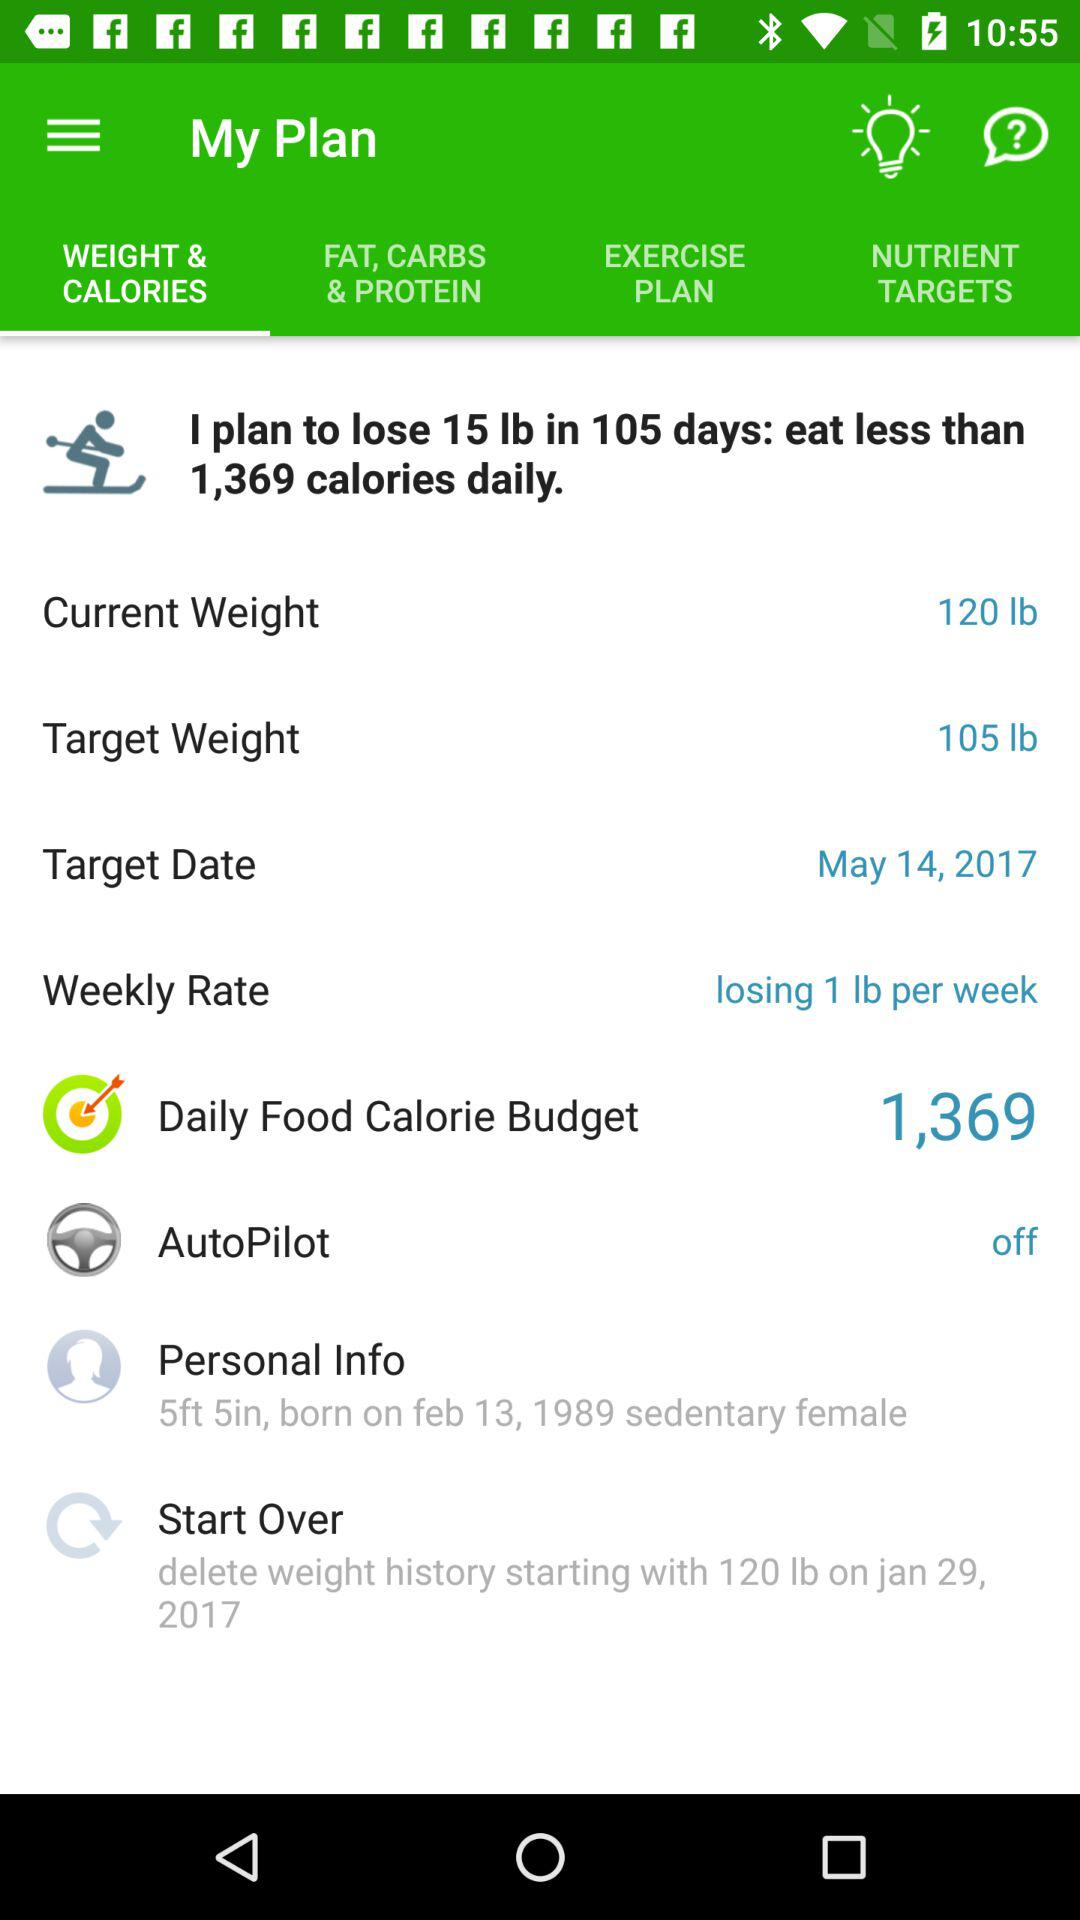What is the weekly rate? The weekly rate is "losing 1 lb per week". 